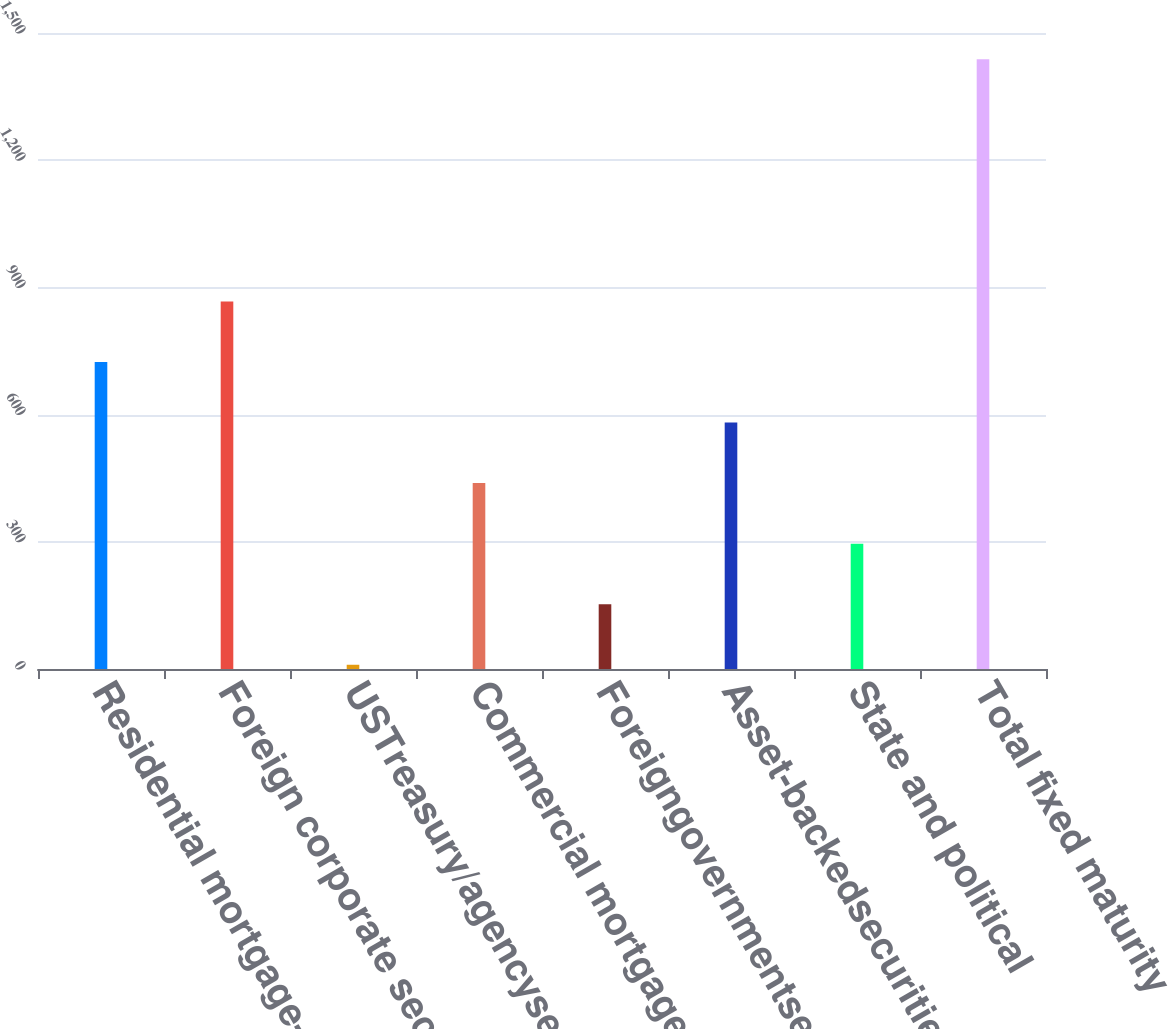Convert chart. <chart><loc_0><loc_0><loc_500><loc_500><bar_chart><fcel>Residential mortgage-backed<fcel>Foreign corporate securities<fcel>USTreasury/agencysecurities<fcel>Commercial mortgage-backed<fcel>Foreigngovernmentsecurities<fcel>Asset-backedsecurities<fcel>State and political<fcel>Total fixed maturity<nl><fcel>724<fcel>866.8<fcel>10<fcel>438.4<fcel>152.8<fcel>581.2<fcel>295.6<fcel>1438<nl></chart> 